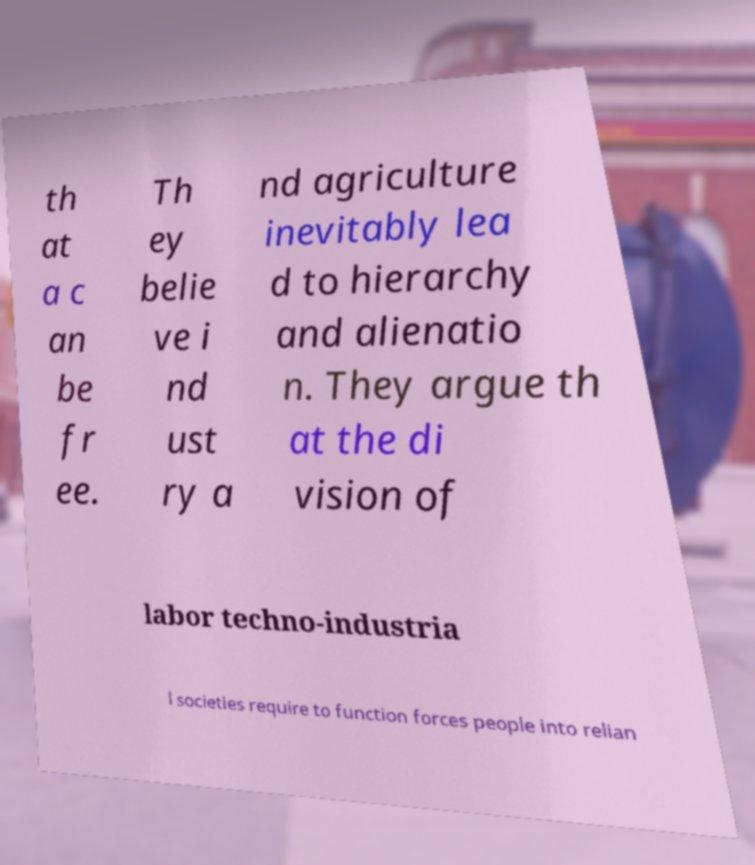Please identify and transcribe the text found in this image. th at a c an be fr ee. Th ey belie ve i nd ust ry a nd agriculture inevitably lea d to hierarchy and alienatio n. They argue th at the di vision of labor techno-industria l societies require to function forces people into relian 